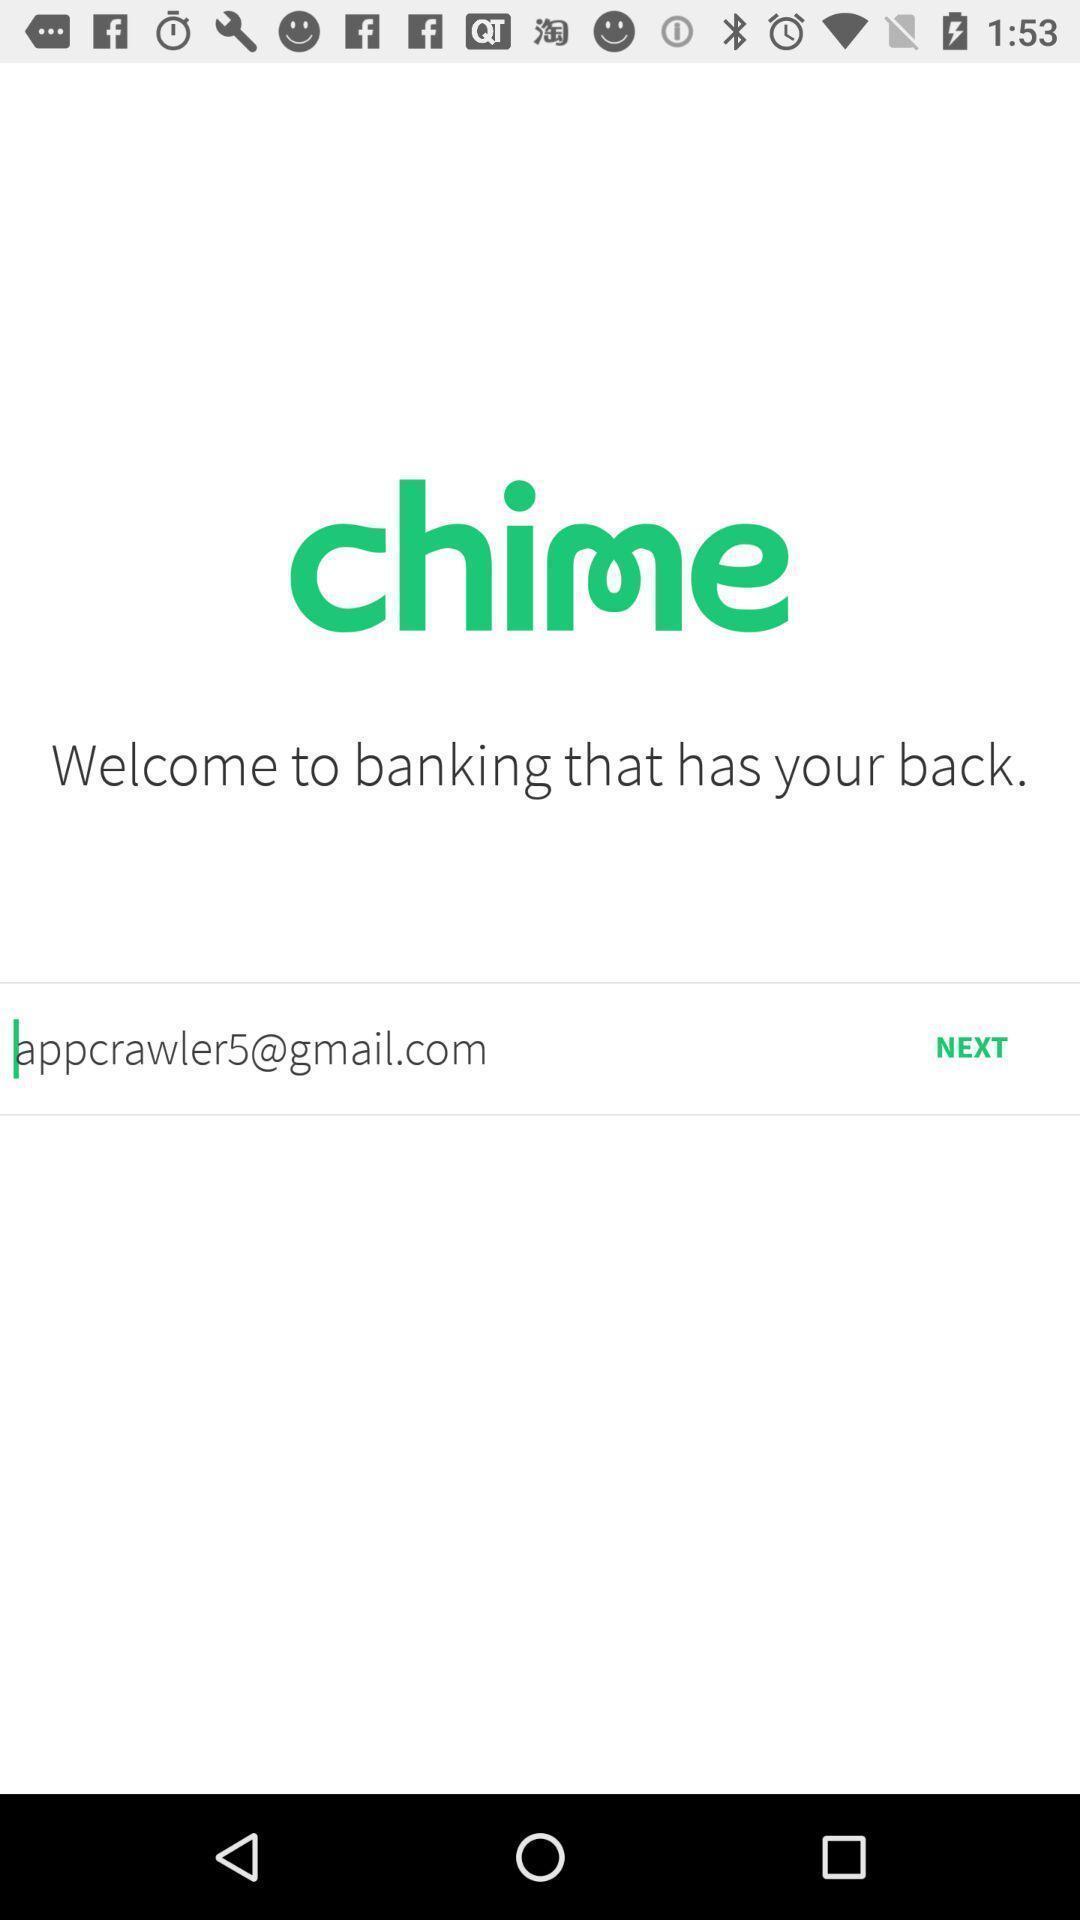Provide a description of this screenshot. Welcome page of a banking app. 